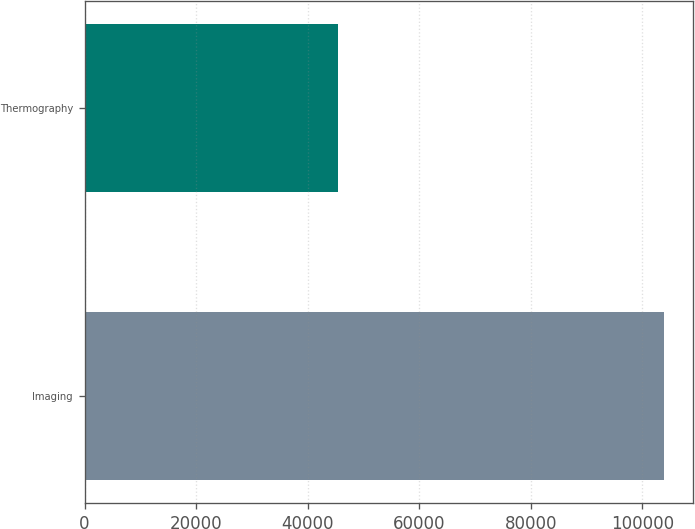Convert chart to OTSL. <chart><loc_0><loc_0><loc_500><loc_500><bar_chart><fcel>Imaging<fcel>Thermography<nl><fcel>103943<fcel>45532<nl></chart> 